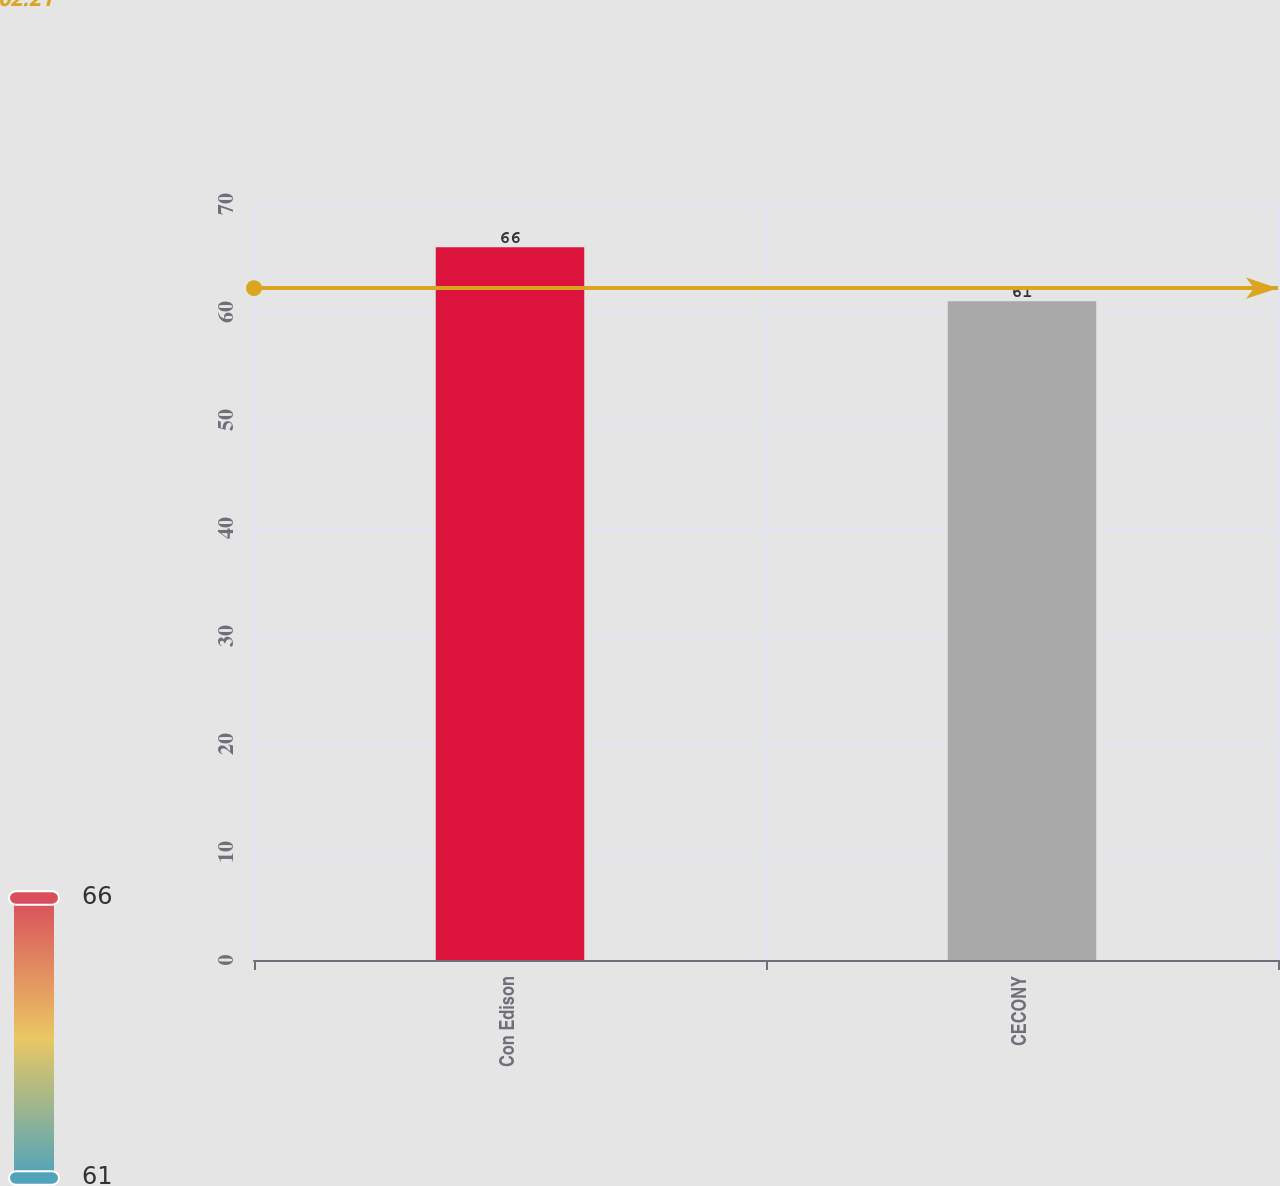Convert chart. <chart><loc_0><loc_0><loc_500><loc_500><bar_chart><fcel>Con Edison<fcel>CECONY<nl><fcel>66<fcel>61<nl></chart> 